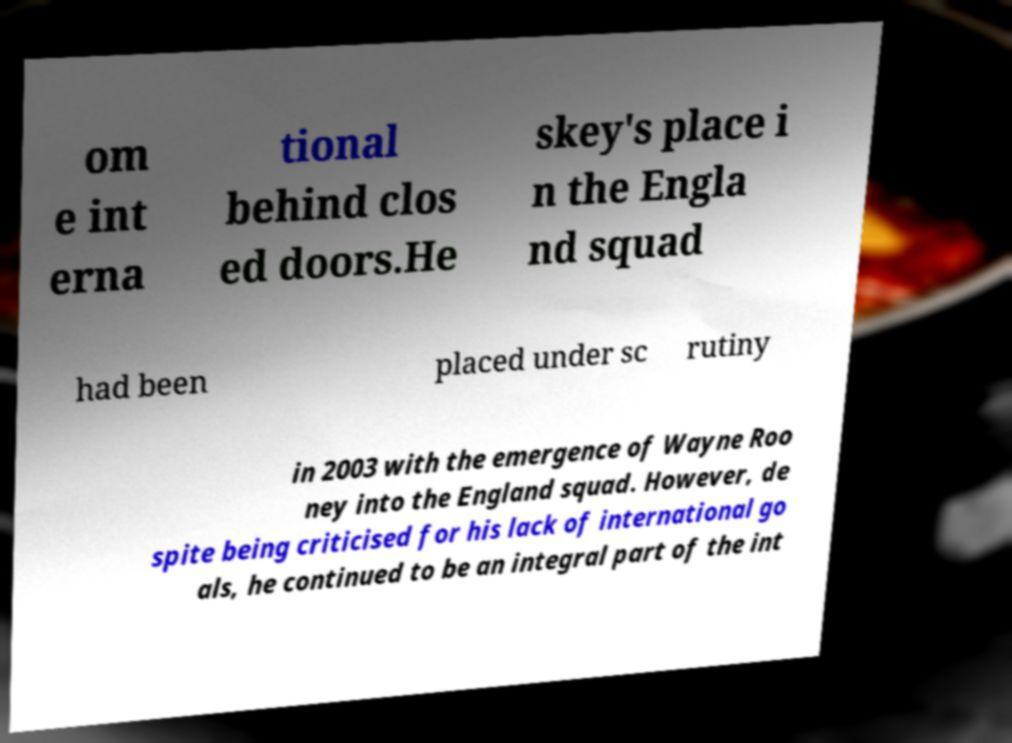There's text embedded in this image that I need extracted. Can you transcribe it verbatim? om e int erna tional behind clos ed doors.He skey's place i n the Engla nd squad had been placed under sc rutiny in 2003 with the emergence of Wayne Roo ney into the England squad. However, de spite being criticised for his lack of international go als, he continued to be an integral part of the int 